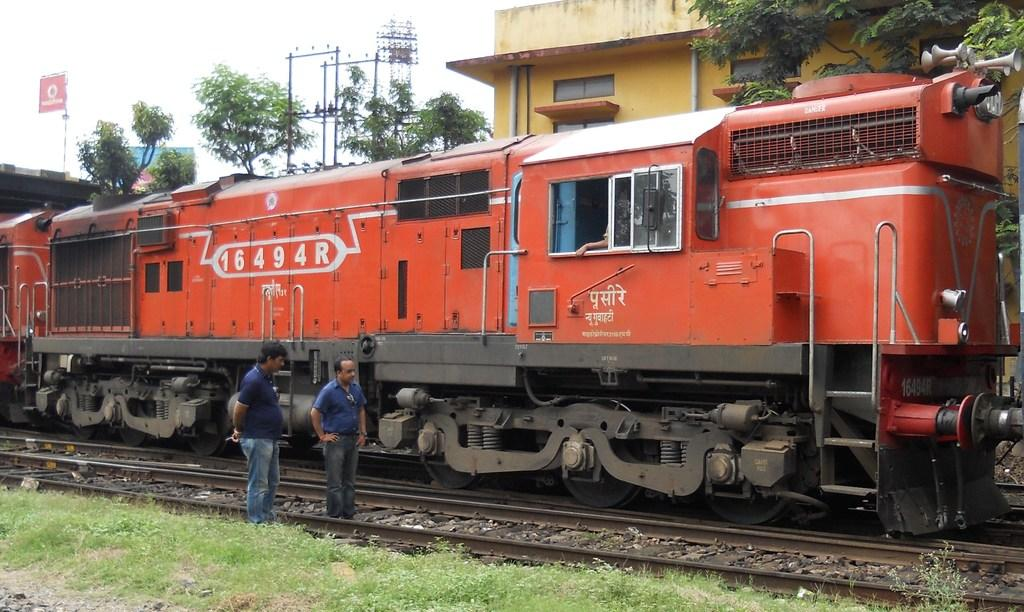<image>
Create a compact narrative representing the image presented. A train that has 16494R printed on the side. 